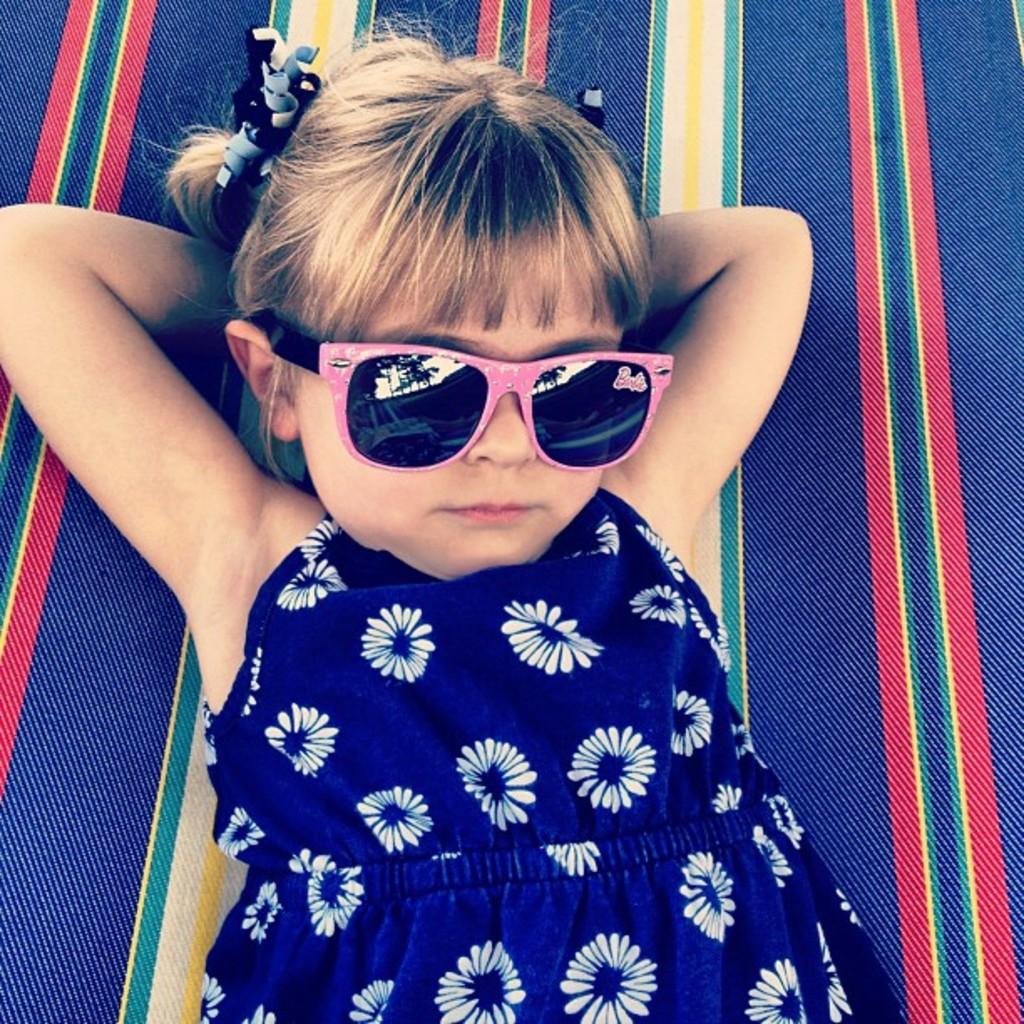Who is the main subject in the picture? There is a girl in the picture. What is the girl wearing on her face? The girl is wearing goggles. What color is the dress the girl is wearing? The girl is wearing a blue dress. What surface is the girl lying on? The girl is lying on a carpet. What type of slope can be seen in the background of the image? There is no slope visible in the background of the image. How many houses are present in the image? There are no houses present in the image. 